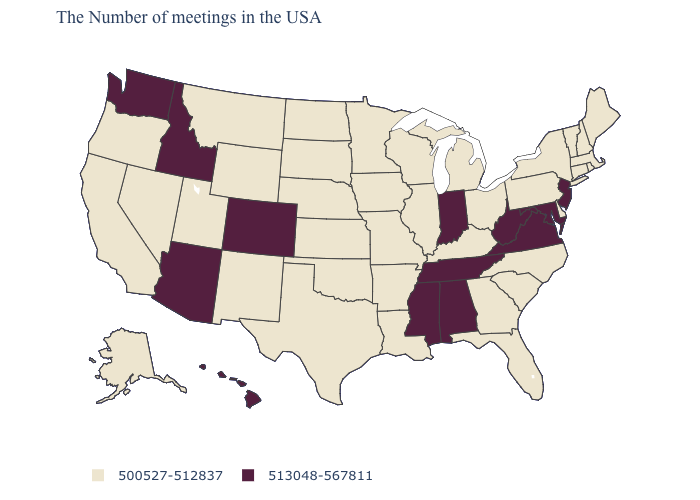What is the highest value in the Northeast ?
Keep it brief. 513048-567811. Which states have the lowest value in the MidWest?
Be succinct. Ohio, Michigan, Wisconsin, Illinois, Missouri, Minnesota, Iowa, Kansas, Nebraska, South Dakota, North Dakota. What is the value of Kansas?
Write a very short answer. 500527-512837. Which states hav the highest value in the West?
Quick response, please. Colorado, Arizona, Idaho, Washington, Hawaii. What is the value of New Jersey?
Give a very brief answer. 513048-567811. Name the states that have a value in the range 513048-567811?
Concise answer only. New Jersey, Maryland, Virginia, West Virginia, Indiana, Alabama, Tennessee, Mississippi, Colorado, Arizona, Idaho, Washington, Hawaii. Which states hav the highest value in the MidWest?
Keep it brief. Indiana. What is the value of South Carolina?
Answer briefly. 500527-512837. What is the value of Hawaii?
Quick response, please. 513048-567811. Is the legend a continuous bar?
Keep it brief. No. Which states hav the highest value in the South?
Give a very brief answer. Maryland, Virginia, West Virginia, Alabama, Tennessee, Mississippi. Does New Hampshire have the lowest value in the USA?
Answer briefly. Yes. What is the value of South Carolina?
Concise answer only. 500527-512837. What is the value of Idaho?
Concise answer only. 513048-567811. Which states have the highest value in the USA?
Short answer required. New Jersey, Maryland, Virginia, West Virginia, Indiana, Alabama, Tennessee, Mississippi, Colorado, Arizona, Idaho, Washington, Hawaii. 